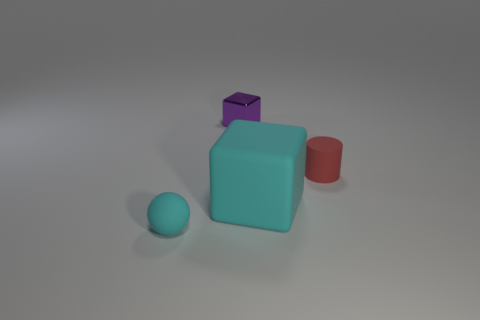Add 3 small purple metallic cubes. How many objects exist? 7 Subtract 0 yellow spheres. How many objects are left? 4 Subtract all blue cubes. Subtract all brown cylinders. How many cubes are left? 2 Subtract all red balls. How many cyan cubes are left? 1 Subtract all cyan things. Subtract all cylinders. How many objects are left? 1 Add 3 small cylinders. How many small cylinders are left? 4 Add 4 spheres. How many spheres exist? 5 